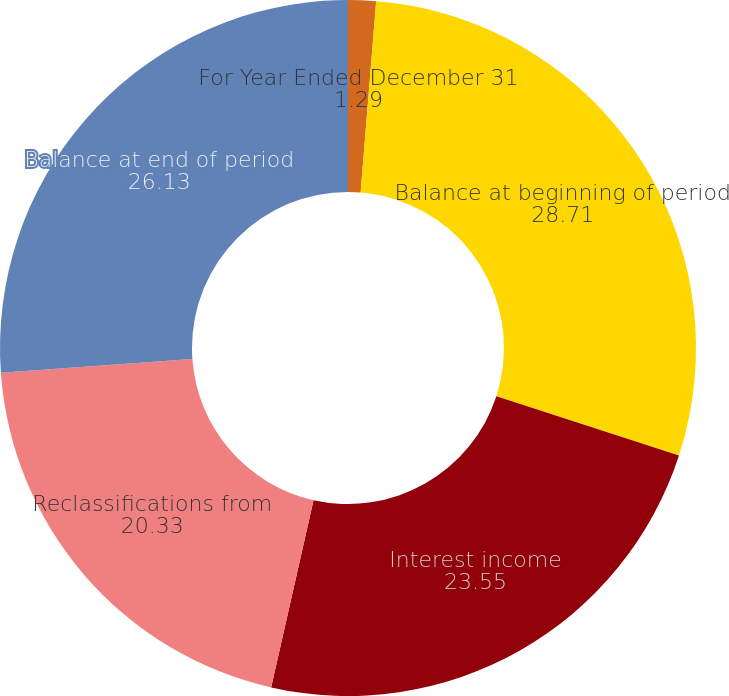Convert chart to OTSL. <chart><loc_0><loc_0><loc_500><loc_500><pie_chart><fcel>For Year Ended December 31<fcel>Balance at beginning of period<fcel>Interest income<fcel>Reclassifications from<fcel>Balance at end of period<nl><fcel>1.29%<fcel>28.71%<fcel>23.55%<fcel>20.33%<fcel>26.13%<nl></chart> 